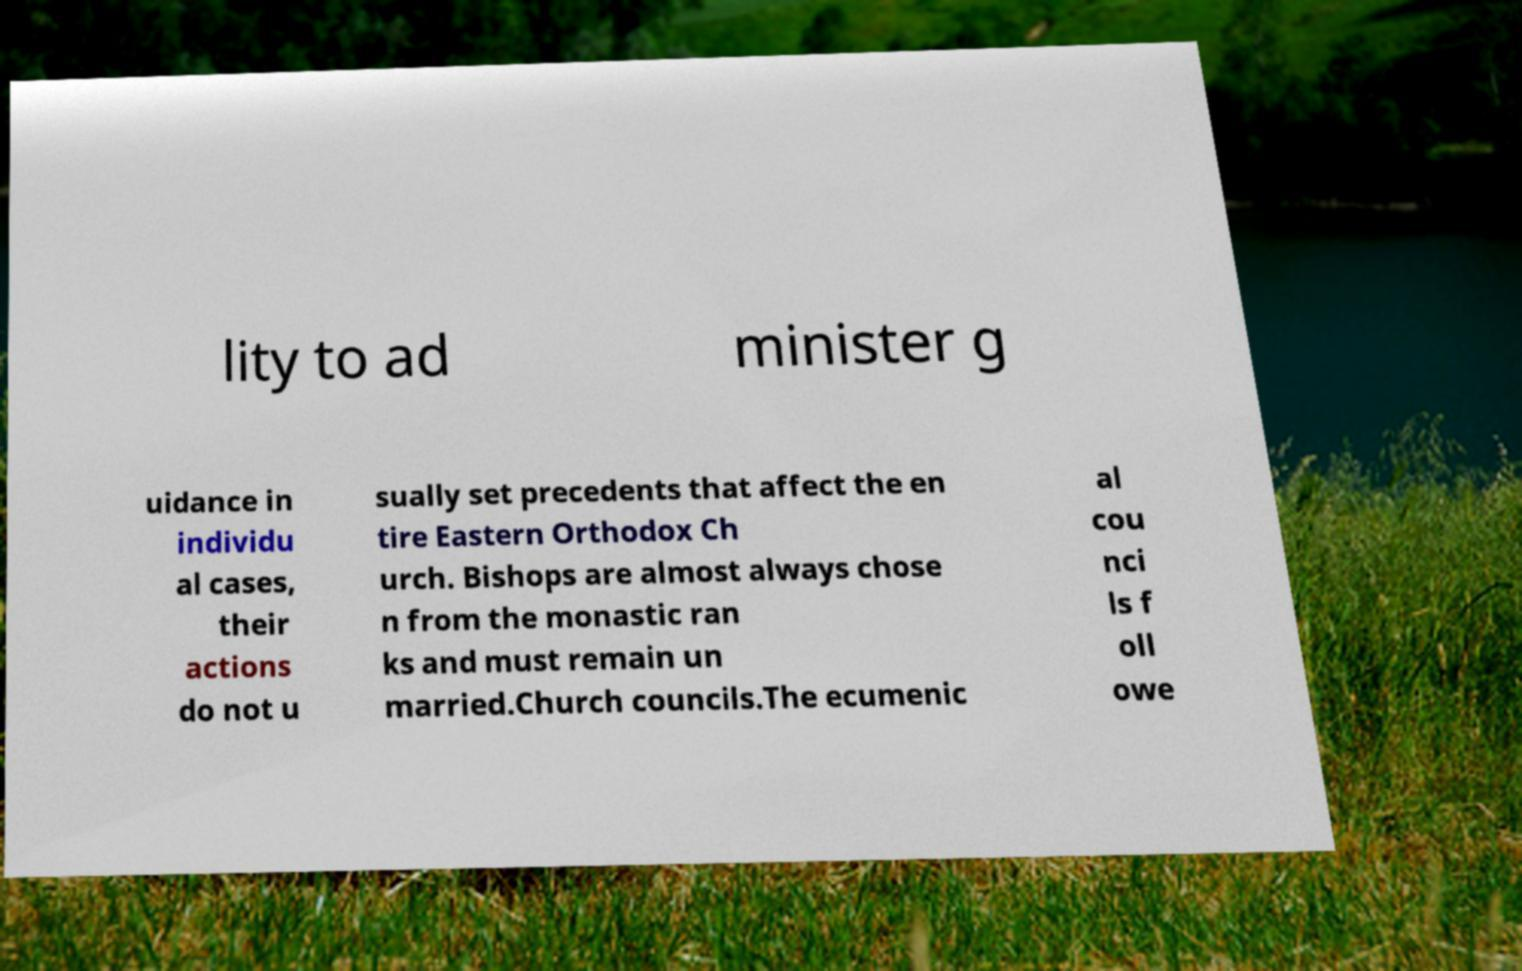Please identify and transcribe the text found in this image. lity to ad minister g uidance in individu al cases, their actions do not u sually set precedents that affect the en tire Eastern Orthodox Ch urch. Bishops are almost always chose n from the monastic ran ks and must remain un married.Church councils.The ecumenic al cou nci ls f oll owe 